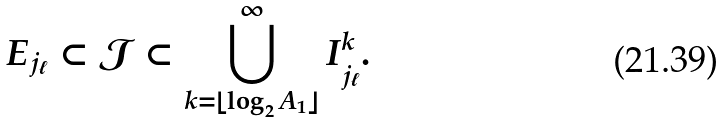Convert formula to latex. <formula><loc_0><loc_0><loc_500><loc_500>E _ { j _ { \ell } } \subset \mathcal { J } \subset \bigcup _ { k = \lfloor \log _ { 2 } A _ { 1 } \rfloor } ^ { \infty } I _ { j _ { \ell } } ^ { k } .</formula> 